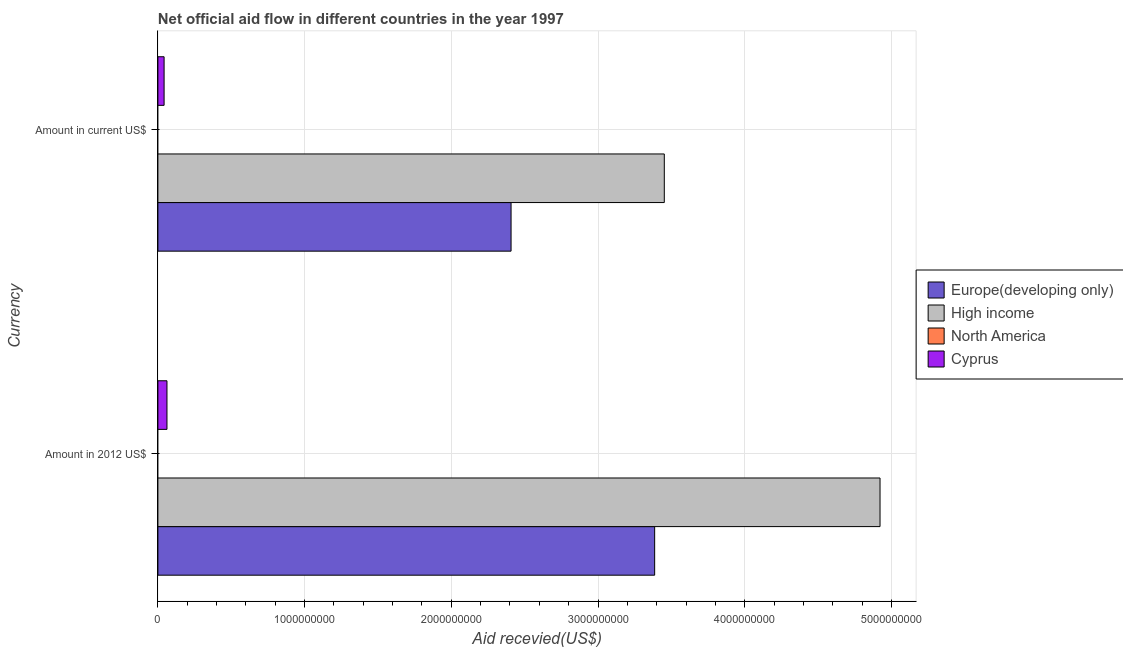How many different coloured bars are there?
Your answer should be very brief. 3. How many groups of bars are there?
Your answer should be very brief. 2. How many bars are there on the 2nd tick from the bottom?
Ensure brevity in your answer.  3. What is the label of the 1st group of bars from the top?
Offer a terse response. Amount in current US$. What is the amount of aid received(expressed in 2012 us$) in Europe(developing only)?
Your response must be concise. 3.39e+09. Across all countries, what is the maximum amount of aid received(expressed in 2012 us$)?
Your answer should be compact. 4.92e+09. What is the total amount of aid received(expressed in 2012 us$) in the graph?
Offer a very short reply. 8.37e+09. What is the difference between the amount of aid received(expressed in us$) in High income and that in Cyprus?
Provide a short and direct response. 3.41e+09. What is the difference between the amount of aid received(expressed in us$) in High income and the amount of aid received(expressed in 2012 us$) in Cyprus?
Your answer should be compact. 3.39e+09. What is the average amount of aid received(expressed in us$) per country?
Provide a succinct answer. 1.48e+09. What is the difference between the amount of aid received(expressed in 2012 us$) and amount of aid received(expressed in us$) in Cyprus?
Keep it short and to the point. 1.96e+07. In how many countries, is the amount of aid received(expressed in 2012 us$) greater than 4200000000 US$?
Your answer should be compact. 1. What is the ratio of the amount of aid received(expressed in us$) in Europe(developing only) to that in High income?
Provide a succinct answer. 0.7. Is the amount of aid received(expressed in us$) in Europe(developing only) less than that in High income?
Provide a short and direct response. Yes. In how many countries, is the amount of aid received(expressed in 2012 us$) greater than the average amount of aid received(expressed in 2012 us$) taken over all countries?
Keep it short and to the point. 2. How many countries are there in the graph?
Provide a short and direct response. 4. Are the values on the major ticks of X-axis written in scientific E-notation?
Keep it short and to the point. No. Does the graph contain any zero values?
Provide a succinct answer. Yes. Where does the legend appear in the graph?
Your answer should be very brief. Center right. How many legend labels are there?
Make the answer very short. 4. What is the title of the graph?
Offer a terse response. Net official aid flow in different countries in the year 1997. What is the label or title of the X-axis?
Offer a terse response. Aid recevied(US$). What is the label or title of the Y-axis?
Your answer should be very brief. Currency. What is the Aid recevied(US$) of Europe(developing only) in Amount in 2012 US$?
Ensure brevity in your answer.  3.39e+09. What is the Aid recevied(US$) of High income in Amount in 2012 US$?
Keep it short and to the point. 4.92e+09. What is the Aid recevied(US$) of North America in Amount in 2012 US$?
Make the answer very short. 0. What is the Aid recevied(US$) of Cyprus in Amount in 2012 US$?
Offer a very short reply. 6.18e+07. What is the Aid recevied(US$) of Europe(developing only) in Amount in current US$?
Your answer should be very brief. 2.41e+09. What is the Aid recevied(US$) of High income in Amount in current US$?
Ensure brevity in your answer.  3.45e+09. What is the Aid recevied(US$) of Cyprus in Amount in current US$?
Offer a very short reply. 4.22e+07. Across all Currency, what is the maximum Aid recevied(US$) of Europe(developing only)?
Keep it short and to the point. 3.39e+09. Across all Currency, what is the maximum Aid recevied(US$) of High income?
Offer a very short reply. 4.92e+09. Across all Currency, what is the maximum Aid recevied(US$) in Cyprus?
Ensure brevity in your answer.  6.18e+07. Across all Currency, what is the minimum Aid recevied(US$) of Europe(developing only)?
Keep it short and to the point. 2.41e+09. Across all Currency, what is the minimum Aid recevied(US$) in High income?
Offer a terse response. 3.45e+09. Across all Currency, what is the minimum Aid recevied(US$) in Cyprus?
Keep it short and to the point. 4.22e+07. What is the total Aid recevied(US$) in Europe(developing only) in the graph?
Offer a terse response. 5.79e+09. What is the total Aid recevied(US$) of High income in the graph?
Your response must be concise. 8.37e+09. What is the total Aid recevied(US$) in Cyprus in the graph?
Offer a very short reply. 1.04e+08. What is the difference between the Aid recevied(US$) of Europe(developing only) in Amount in 2012 US$ and that in Amount in current US$?
Your response must be concise. 9.79e+08. What is the difference between the Aid recevied(US$) of High income in Amount in 2012 US$ and that in Amount in current US$?
Keep it short and to the point. 1.47e+09. What is the difference between the Aid recevied(US$) in Cyprus in Amount in 2012 US$ and that in Amount in current US$?
Offer a terse response. 1.96e+07. What is the difference between the Aid recevied(US$) of Europe(developing only) in Amount in 2012 US$ and the Aid recevied(US$) of High income in Amount in current US$?
Ensure brevity in your answer.  -6.56e+07. What is the difference between the Aid recevied(US$) of Europe(developing only) in Amount in 2012 US$ and the Aid recevied(US$) of Cyprus in Amount in current US$?
Provide a succinct answer. 3.34e+09. What is the difference between the Aid recevied(US$) of High income in Amount in 2012 US$ and the Aid recevied(US$) of Cyprus in Amount in current US$?
Provide a succinct answer. 4.88e+09. What is the average Aid recevied(US$) in Europe(developing only) per Currency?
Make the answer very short. 2.90e+09. What is the average Aid recevied(US$) in High income per Currency?
Your answer should be very brief. 4.19e+09. What is the average Aid recevied(US$) in North America per Currency?
Your answer should be very brief. 0. What is the average Aid recevied(US$) in Cyprus per Currency?
Ensure brevity in your answer.  5.20e+07. What is the difference between the Aid recevied(US$) of Europe(developing only) and Aid recevied(US$) of High income in Amount in 2012 US$?
Offer a terse response. -1.54e+09. What is the difference between the Aid recevied(US$) in Europe(developing only) and Aid recevied(US$) in Cyprus in Amount in 2012 US$?
Give a very brief answer. 3.32e+09. What is the difference between the Aid recevied(US$) in High income and Aid recevied(US$) in Cyprus in Amount in 2012 US$?
Make the answer very short. 4.86e+09. What is the difference between the Aid recevied(US$) in Europe(developing only) and Aid recevied(US$) in High income in Amount in current US$?
Your answer should be very brief. -1.04e+09. What is the difference between the Aid recevied(US$) of Europe(developing only) and Aid recevied(US$) of Cyprus in Amount in current US$?
Offer a terse response. 2.37e+09. What is the difference between the Aid recevied(US$) of High income and Aid recevied(US$) of Cyprus in Amount in current US$?
Your answer should be compact. 3.41e+09. What is the ratio of the Aid recevied(US$) in Europe(developing only) in Amount in 2012 US$ to that in Amount in current US$?
Your response must be concise. 1.41. What is the ratio of the Aid recevied(US$) in High income in Amount in 2012 US$ to that in Amount in current US$?
Your response must be concise. 1.43. What is the ratio of the Aid recevied(US$) in Cyprus in Amount in 2012 US$ to that in Amount in current US$?
Give a very brief answer. 1.46. What is the difference between the highest and the second highest Aid recevied(US$) in Europe(developing only)?
Make the answer very short. 9.79e+08. What is the difference between the highest and the second highest Aid recevied(US$) in High income?
Your answer should be very brief. 1.47e+09. What is the difference between the highest and the second highest Aid recevied(US$) in Cyprus?
Offer a terse response. 1.96e+07. What is the difference between the highest and the lowest Aid recevied(US$) of Europe(developing only)?
Provide a short and direct response. 9.79e+08. What is the difference between the highest and the lowest Aid recevied(US$) in High income?
Your answer should be very brief. 1.47e+09. What is the difference between the highest and the lowest Aid recevied(US$) of Cyprus?
Provide a short and direct response. 1.96e+07. 